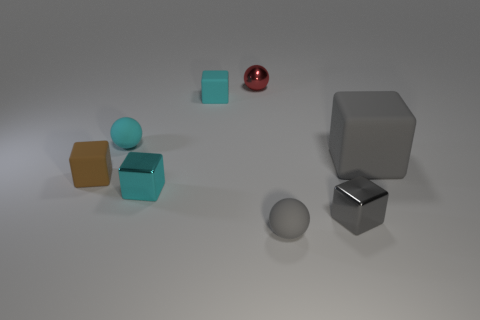Subtract all gray cylinders. How many gray blocks are left? 2 Subtract all gray matte blocks. How many blocks are left? 4 Subtract 3 blocks. How many blocks are left? 2 Subtract all brown cubes. How many cubes are left? 4 Subtract all green cubes. Subtract all red cylinders. How many cubes are left? 5 Subtract all spheres. How many objects are left? 5 Add 7 cyan matte cubes. How many cyan matte cubes exist? 8 Subtract 1 brown cubes. How many objects are left? 7 Subtract all big gray blocks. Subtract all red spheres. How many objects are left? 6 Add 6 small cyan metal objects. How many small cyan metal objects are left? 7 